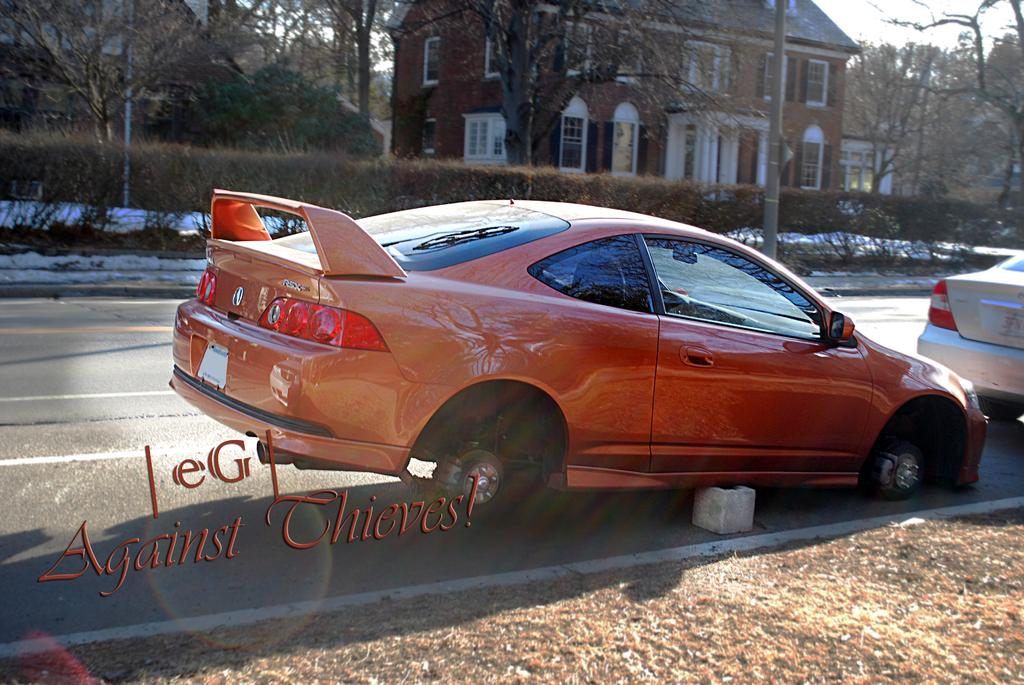How many vehicles can be seen on the road in the image? There are two vehicles visible on the road in the image. What is written on the back side of one of the vehicles? There is text visible on the back side of one of the vehicles. What type of structure can be seen at the top of the image? There is a building visible at the top of the image. What type of vegetation is present in the image? Trees and bushes are visible in the image. What size sheet is being used to cover the baby in the image? There is no baby or sheet present in the image. 